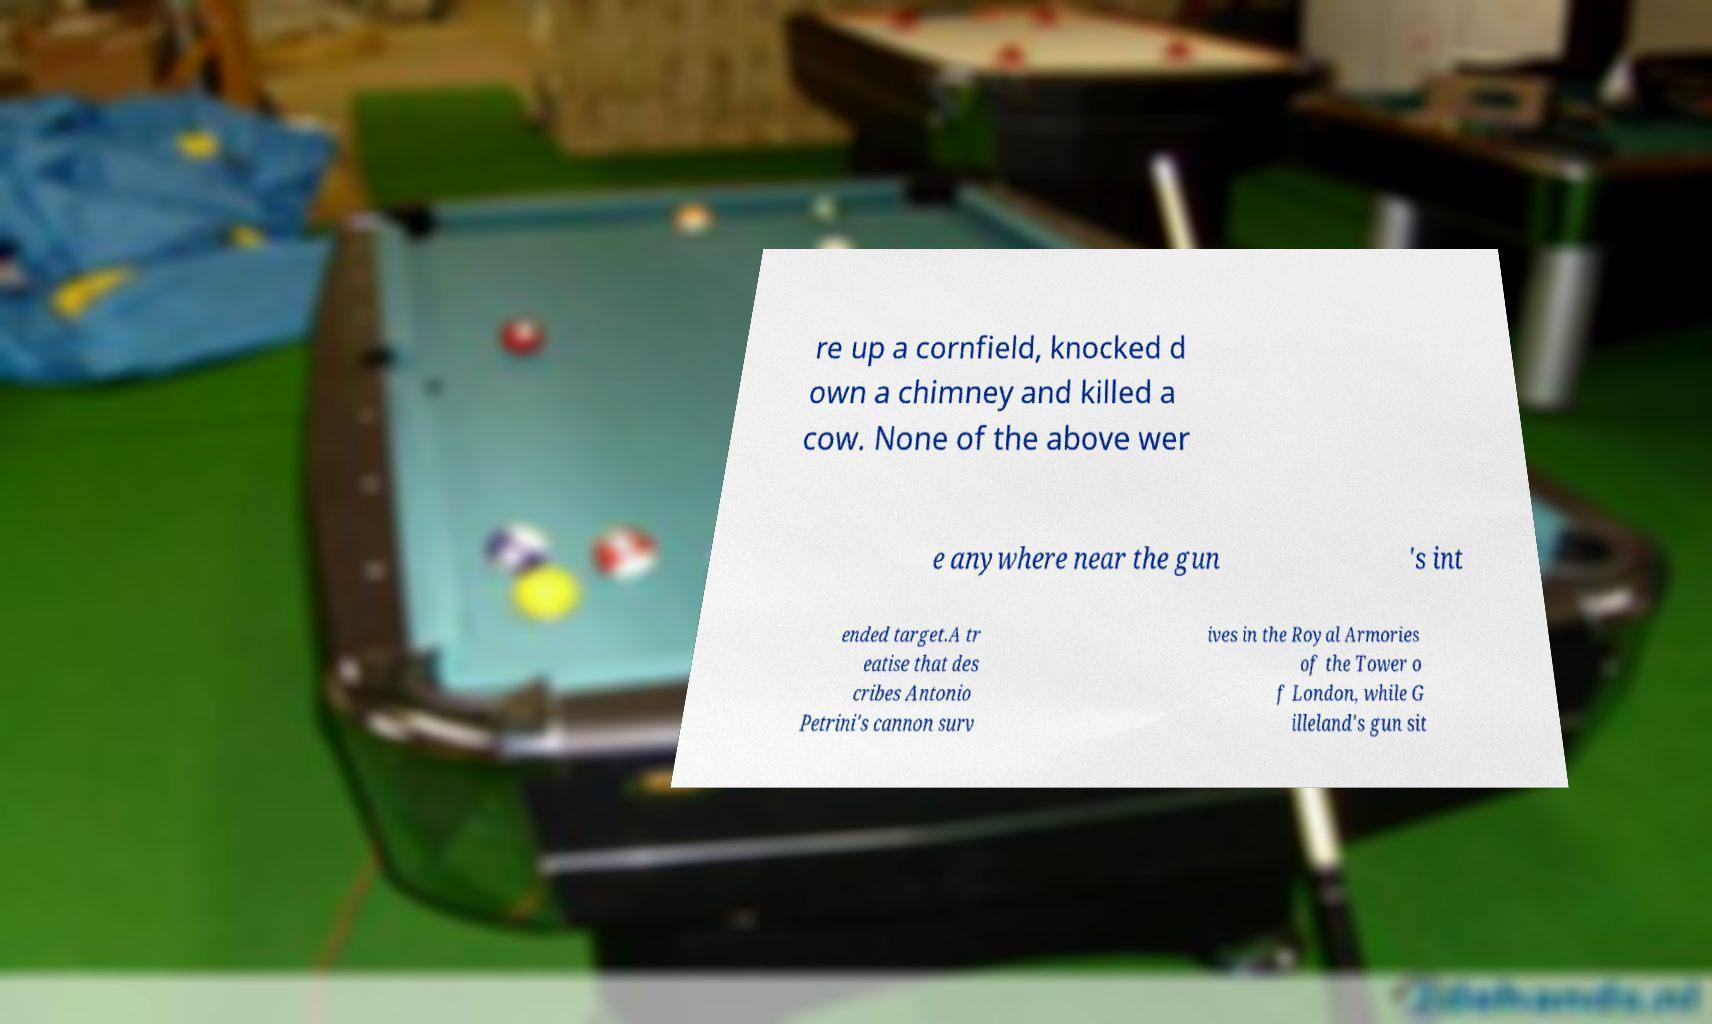Please read and relay the text visible in this image. What does it say? re up a cornfield, knocked d own a chimney and killed a cow. None of the above wer e anywhere near the gun 's int ended target.A tr eatise that des cribes Antonio Petrini's cannon surv ives in the Royal Armories of the Tower o f London, while G illeland's gun sit 